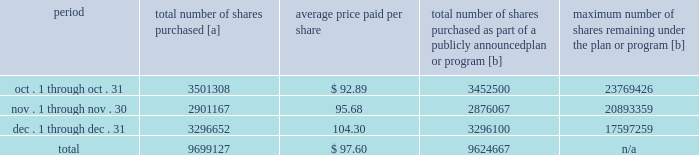Five-year performance comparison 2013 the following graph provides an indicator of cumulative total shareholder returns for the corporation as compared to the peer group index ( described above ) , the dj trans , and the s&p 500 .
The graph assumes that $ 100 was invested in the common stock of union pacific corporation and each index on december 31 , 2011 and that all dividends were reinvested .
The information below is historical in nature and is not necessarily indicative of future performance .
Purchases of equity securities 2013 during 2016 , we repurchased 35686529 shares of our common stock at an average price of $ 88.36 .
The table presents common stock repurchases during each month for the fourth quarter of 2016 : period total number of shares purchased [a] average price paid per share total number of shares purchased as part of a publicly announced plan or program [b] maximum number of shares remaining under the plan or program [b] .
[a] total number of shares purchased during the quarter includes approximately 74460 shares delivered or attested to upc by employees to pay stock option exercise prices , satisfy excess tax withholding obligations for stock option exercises or vesting of retention units , and pay withholding obligations for vesting of retention shares .
[b] effective january 1 , 2014 , our board of directors authorized the repurchase of up to 120 million shares of our common stock by december 31 , 2017 .
These repurchases may be made on the open market or through other transactions .
Our management has sole discretion with respect to determining the timing and amount of these transactions .
On november 17 , 2016 , our board of directors approved the early renewal of the share repurchase program , authorizing the repurchase of up to 120 million shares of our common stock by december 31 , 2020 .
The new authorization was effective january 1 , 2017 , and replaces the previous authorization , which expired on december 31 , 2016. .
For the fourth quarter of 2016 what was the total number of shares purchased in december? 
Computations: (3296652 / 9699127)
Answer: 0.33989. 